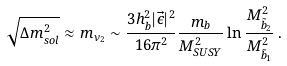<formula> <loc_0><loc_0><loc_500><loc_500>\sqrt { \Delta m _ { s o l } ^ { 2 } } \approx m _ { \nu _ { 2 } } \sim { \frac { 3 h _ { b } ^ { 2 } | \vec { \epsilon } | ^ { 2 } } { 1 6 \pi ^ { 2 } } } { \frac { m _ { b } } { M _ { S U S Y } ^ { 2 } } } \ln { \frac { M _ { \tilde { b } _ { 2 } } ^ { 2 } } { M _ { \tilde { b } _ { 1 } } ^ { 2 } } } \, .</formula> 